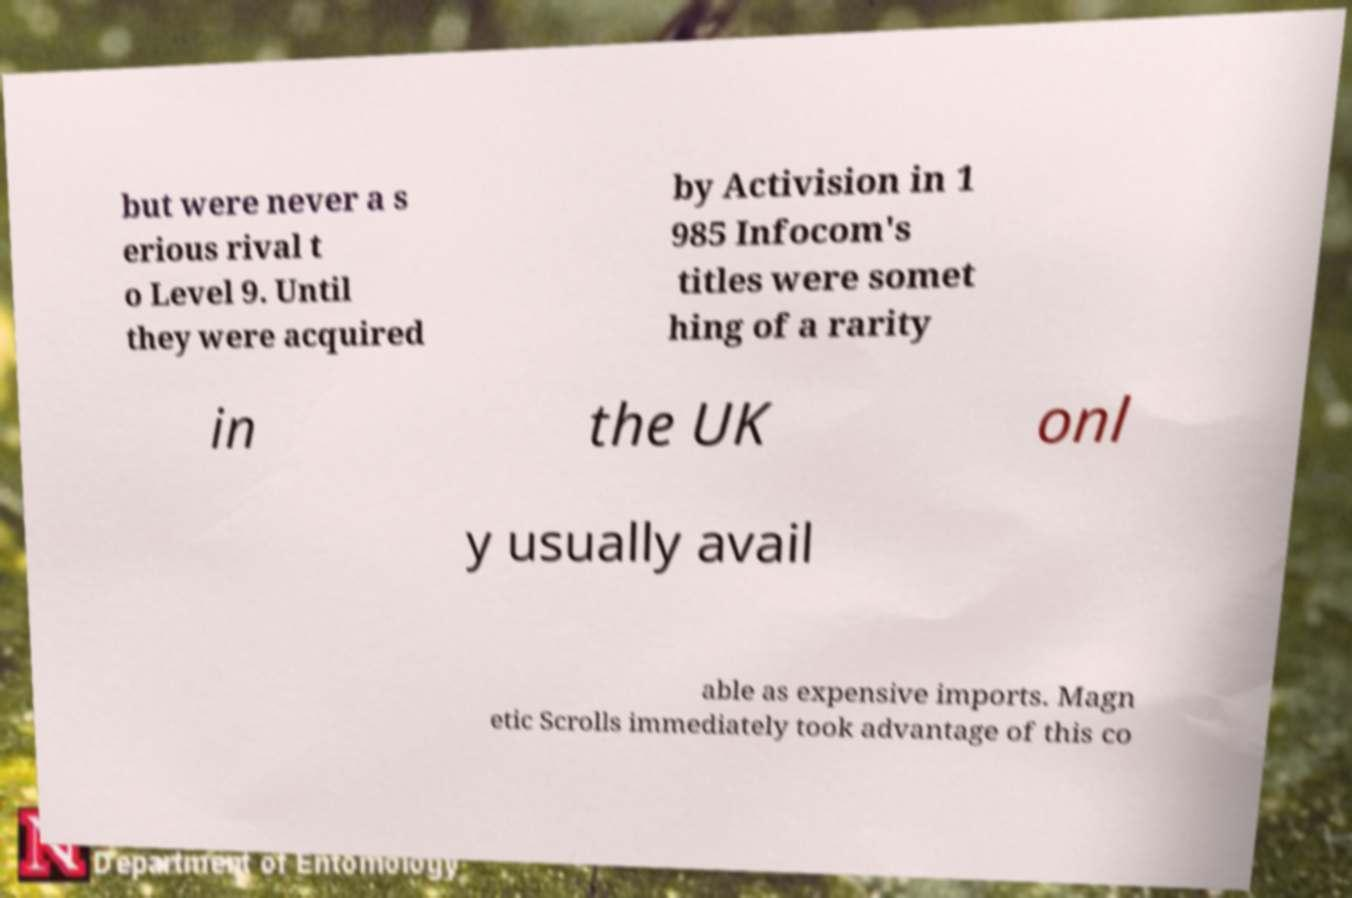Can you read and provide the text displayed in the image?This photo seems to have some interesting text. Can you extract and type it out for me? but were never a s erious rival t o Level 9. Until they were acquired by Activision in 1 985 Infocom's titles were somet hing of a rarity in the UK onl y usually avail able as expensive imports. Magn etic Scrolls immediately took advantage of this co 